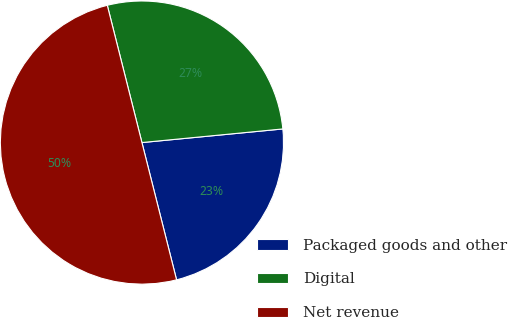Convert chart to OTSL. <chart><loc_0><loc_0><loc_500><loc_500><pie_chart><fcel>Packaged goods and other<fcel>Digital<fcel>Net revenue<nl><fcel>22.6%<fcel>27.4%<fcel>50.0%<nl></chart> 